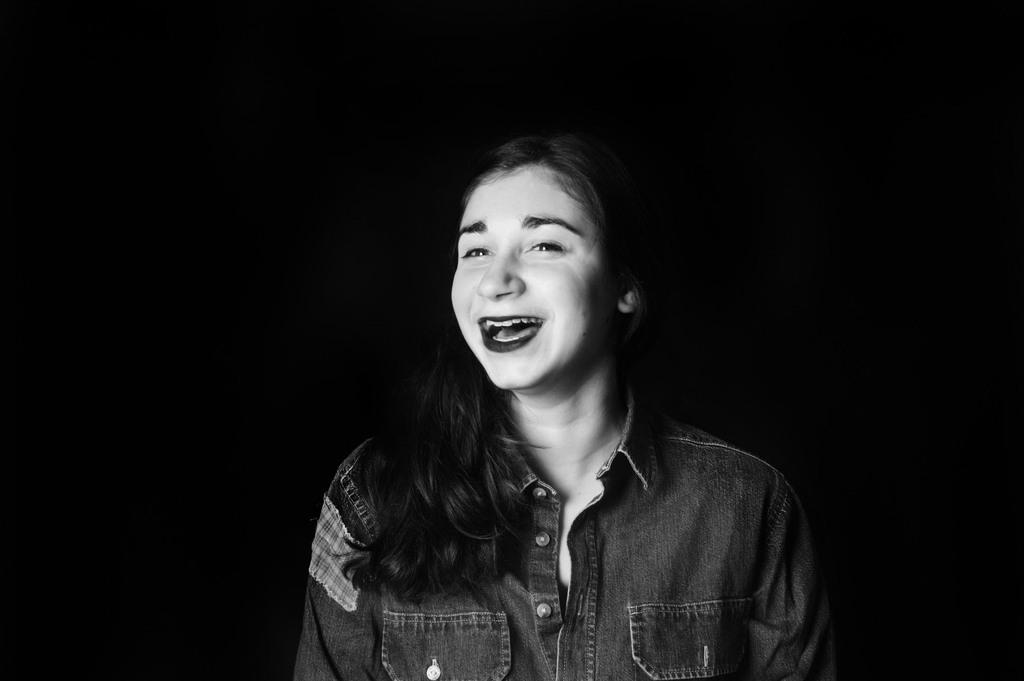What is the color scheme of the image? The image is black and white. Who is present in the image? There is a woman in the image. How is the woman's facial expression? The woman has a smiling face. What color is the background of the image? The background of the image is black. What type of bead is the woman wearing in the image? There is no bead visible in the image. How does the woman become an expert in the image? There is no indication in the image that the woman is becoming an expert or has any specific expertise. 